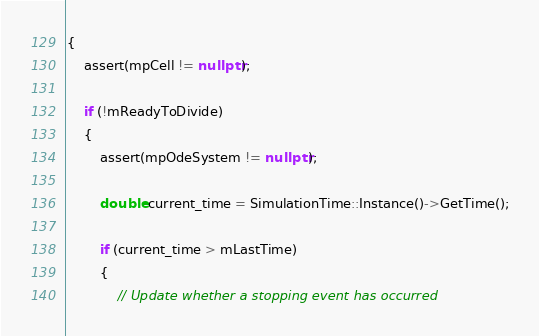<code> <loc_0><loc_0><loc_500><loc_500><_C++_>{
    assert(mpCell != nullptr);

    if (!mReadyToDivide)
    {
        assert(mpOdeSystem != nullptr);

        double current_time = SimulationTime::Instance()->GetTime();

        if (current_time > mLastTime)
        {
            // Update whether a stopping event has occurred</code> 